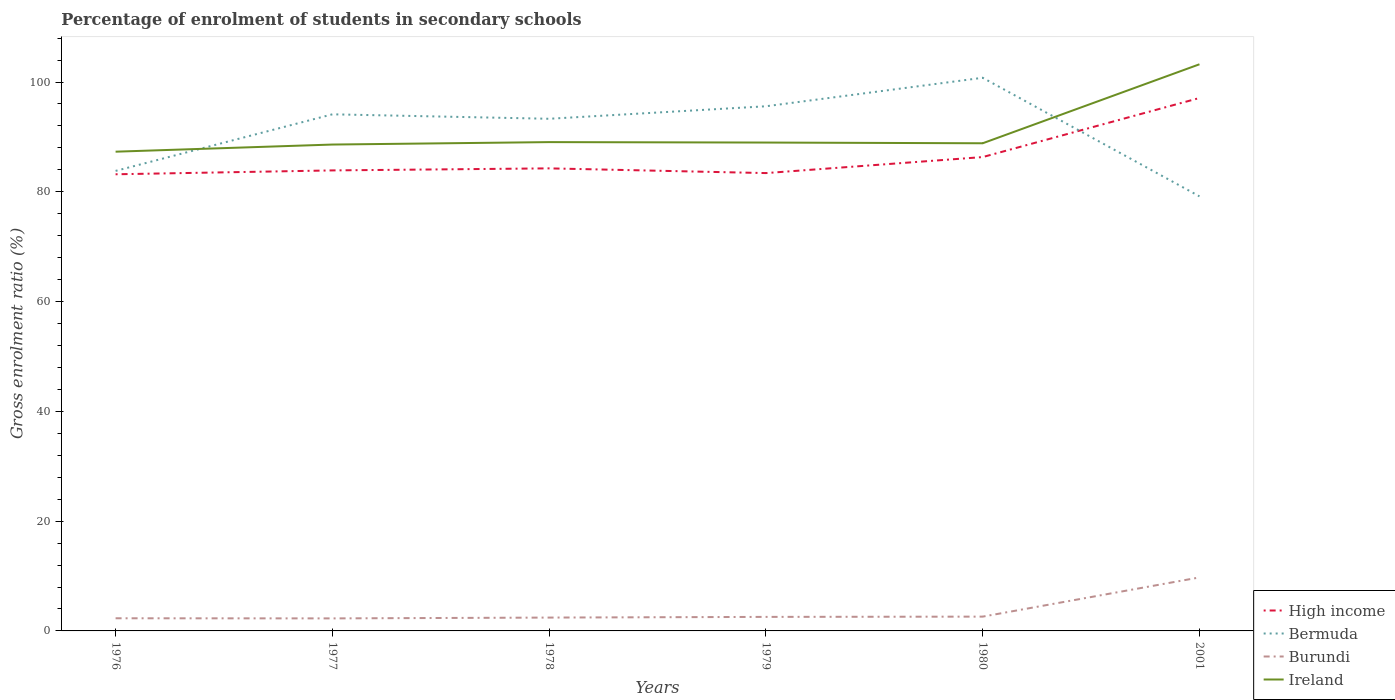How many different coloured lines are there?
Your answer should be compact. 4. Is the number of lines equal to the number of legend labels?
Offer a terse response. Yes. Across all years, what is the maximum percentage of students enrolled in secondary schools in Bermuda?
Keep it short and to the point. 79.17. In which year was the percentage of students enrolled in secondary schools in High income maximum?
Your response must be concise. 1976. What is the total percentage of students enrolled in secondary schools in Bermuda in the graph?
Your response must be concise. 21.6. What is the difference between the highest and the second highest percentage of students enrolled in secondary schools in Bermuda?
Make the answer very short. 21.6. Is the percentage of students enrolled in secondary schools in High income strictly greater than the percentage of students enrolled in secondary schools in Ireland over the years?
Ensure brevity in your answer.  Yes. How many years are there in the graph?
Keep it short and to the point. 6. Does the graph contain any zero values?
Make the answer very short. No. Does the graph contain grids?
Provide a succinct answer. No. What is the title of the graph?
Offer a very short reply. Percentage of enrolment of students in secondary schools. Does "Ghana" appear as one of the legend labels in the graph?
Your response must be concise. No. What is the label or title of the Y-axis?
Provide a short and direct response. Gross enrolment ratio (%). What is the Gross enrolment ratio (%) in High income in 1976?
Give a very brief answer. 83.19. What is the Gross enrolment ratio (%) of Bermuda in 1976?
Offer a terse response. 83.81. What is the Gross enrolment ratio (%) of Burundi in 1976?
Your answer should be compact. 2.3. What is the Gross enrolment ratio (%) of Ireland in 1976?
Your answer should be compact. 87.31. What is the Gross enrolment ratio (%) in High income in 1977?
Keep it short and to the point. 83.9. What is the Gross enrolment ratio (%) in Bermuda in 1977?
Give a very brief answer. 94.12. What is the Gross enrolment ratio (%) of Burundi in 1977?
Offer a very short reply. 2.28. What is the Gross enrolment ratio (%) in Ireland in 1977?
Your answer should be compact. 88.61. What is the Gross enrolment ratio (%) in High income in 1978?
Give a very brief answer. 84.27. What is the Gross enrolment ratio (%) of Bermuda in 1978?
Your answer should be compact. 93.31. What is the Gross enrolment ratio (%) in Burundi in 1978?
Offer a terse response. 2.43. What is the Gross enrolment ratio (%) of Ireland in 1978?
Keep it short and to the point. 89.05. What is the Gross enrolment ratio (%) in High income in 1979?
Give a very brief answer. 83.41. What is the Gross enrolment ratio (%) in Bermuda in 1979?
Keep it short and to the point. 95.59. What is the Gross enrolment ratio (%) of Burundi in 1979?
Give a very brief answer. 2.56. What is the Gross enrolment ratio (%) in Ireland in 1979?
Offer a terse response. 88.98. What is the Gross enrolment ratio (%) of High income in 1980?
Give a very brief answer. 86.33. What is the Gross enrolment ratio (%) of Bermuda in 1980?
Offer a terse response. 100.78. What is the Gross enrolment ratio (%) in Burundi in 1980?
Provide a succinct answer. 2.6. What is the Gross enrolment ratio (%) of Ireland in 1980?
Offer a very short reply. 88.84. What is the Gross enrolment ratio (%) in High income in 2001?
Your response must be concise. 97.09. What is the Gross enrolment ratio (%) of Bermuda in 2001?
Keep it short and to the point. 79.17. What is the Gross enrolment ratio (%) of Burundi in 2001?
Give a very brief answer. 9.75. What is the Gross enrolment ratio (%) of Ireland in 2001?
Provide a short and direct response. 103.23. Across all years, what is the maximum Gross enrolment ratio (%) of High income?
Offer a terse response. 97.09. Across all years, what is the maximum Gross enrolment ratio (%) in Bermuda?
Ensure brevity in your answer.  100.78. Across all years, what is the maximum Gross enrolment ratio (%) in Burundi?
Offer a very short reply. 9.75. Across all years, what is the maximum Gross enrolment ratio (%) in Ireland?
Ensure brevity in your answer.  103.23. Across all years, what is the minimum Gross enrolment ratio (%) in High income?
Ensure brevity in your answer.  83.19. Across all years, what is the minimum Gross enrolment ratio (%) of Bermuda?
Make the answer very short. 79.17. Across all years, what is the minimum Gross enrolment ratio (%) of Burundi?
Make the answer very short. 2.28. Across all years, what is the minimum Gross enrolment ratio (%) of Ireland?
Offer a very short reply. 87.31. What is the total Gross enrolment ratio (%) of High income in the graph?
Offer a very short reply. 518.2. What is the total Gross enrolment ratio (%) of Bermuda in the graph?
Your response must be concise. 546.77. What is the total Gross enrolment ratio (%) of Burundi in the graph?
Offer a very short reply. 21.92. What is the total Gross enrolment ratio (%) in Ireland in the graph?
Provide a short and direct response. 546.03. What is the difference between the Gross enrolment ratio (%) in High income in 1976 and that in 1977?
Offer a very short reply. -0.71. What is the difference between the Gross enrolment ratio (%) of Bermuda in 1976 and that in 1977?
Provide a succinct answer. -10.31. What is the difference between the Gross enrolment ratio (%) of Burundi in 1976 and that in 1977?
Make the answer very short. 0.02. What is the difference between the Gross enrolment ratio (%) of Ireland in 1976 and that in 1977?
Provide a succinct answer. -1.3. What is the difference between the Gross enrolment ratio (%) in High income in 1976 and that in 1978?
Provide a succinct answer. -1.08. What is the difference between the Gross enrolment ratio (%) in Bermuda in 1976 and that in 1978?
Keep it short and to the point. -9.5. What is the difference between the Gross enrolment ratio (%) in Burundi in 1976 and that in 1978?
Your answer should be compact. -0.13. What is the difference between the Gross enrolment ratio (%) of Ireland in 1976 and that in 1978?
Offer a very short reply. -1.75. What is the difference between the Gross enrolment ratio (%) in High income in 1976 and that in 1979?
Give a very brief answer. -0.22. What is the difference between the Gross enrolment ratio (%) in Bermuda in 1976 and that in 1979?
Make the answer very short. -11.78. What is the difference between the Gross enrolment ratio (%) of Burundi in 1976 and that in 1979?
Ensure brevity in your answer.  -0.25. What is the difference between the Gross enrolment ratio (%) of Ireland in 1976 and that in 1979?
Your response must be concise. -1.67. What is the difference between the Gross enrolment ratio (%) in High income in 1976 and that in 1980?
Your answer should be compact. -3.13. What is the difference between the Gross enrolment ratio (%) of Bermuda in 1976 and that in 1980?
Offer a very short reply. -16.97. What is the difference between the Gross enrolment ratio (%) in Burundi in 1976 and that in 1980?
Ensure brevity in your answer.  -0.3. What is the difference between the Gross enrolment ratio (%) of Ireland in 1976 and that in 1980?
Keep it short and to the point. -1.53. What is the difference between the Gross enrolment ratio (%) of High income in 1976 and that in 2001?
Provide a short and direct response. -13.9. What is the difference between the Gross enrolment ratio (%) in Bermuda in 1976 and that in 2001?
Give a very brief answer. 4.63. What is the difference between the Gross enrolment ratio (%) of Burundi in 1976 and that in 2001?
Your response must be concise. -7.44. What is the difference between the Gross enrolment ratio (%) of Ireland in 1976 and that in 2001?
Ensure brevity in your answer.  -15.93. What is the difference between the Gross enrolment ratio (%) in High income in 1977 and that in 1978?
Ensure brevity in your answer.  -0.37. What is the difference between the Gross enrolment ratio (%) in Bermuda in 1977 and that in 1978?
Provide a succinct answer. 0.81. What is the difference between the Gross enrolment ratio (%) in Burundi in 1977 and that in 1978?
Provide a succinct answer. -0.15. What is the difference between the Gross enrolment ratio (%) of Ireland in 1977 and that in 1978?
Keep it short and to the point. -0.44. What is the difference between the Gross enrolment ratio (%) in High income in 1977 and that in 1979?
Make the answer very short. 0.49. What is the difference between the Gross enrolment ratio (%) in Bermuda in 1977 and that in 1979?
Provide a short and direct response. -1.47. What is the difference between the Gross enrolment ratio (%) in Burundi in 1977 and that in 1979?
Keep it short and to the point. -0.27. What is the difference between the Gross enrolment ratio (%) of Ireland in 1977 and that in 1979?
Your answer should be very brief. -0.36. What is the difference between the Gross enrolment ratio (%) in High income in 1977 and that in 1980?
Keep it short and to the point. -2.43. What is the difference between the Gross enrolment ratio (%) of Bermuda in 1977 and that in 1980?
Your response must be concise. -6.66. What is the difference between the Gross enrolment ratio (%) in Burundi in 1977 and that in 1980?
Offer a very short reply. -0.32. What is the difference between the Gross enrolment ratio (%) in Ireland in 1977 and that in 1980?
Your answer should be compact. -0.23. What is the difference between the Gross enrolment ratio (%) in High income in 1977 and that in 2001?
Your response must be concise. -13.19. What is the difference between the Gross enrolment ratio (%) in Bermuda in 1977 and that in 2001?
Offer a terse response. 14.94. What is the difference between the Gross enrolment ratio (%) in Burundi in 1977 and that in 2001?
Your answer should be very brief. -7.46. What is the difference between the Gross enrolment ratio (%) in Ireland in 1977 and that in 2001?
Make the answer very short. -14.62. What is the difference between the Gross enrolment ratio (%) in High income in 1978 and that in 1979?
Your response must be concise. 0.86. What is the difference between the Gross enrolment ratio (%) of Bermuda in 1978 and that in 1979?
Provide a succinct answer. -2.28. What is the difference between the Gross enrolment ratio (%) of Burundi in 1978 and that in 1979?
Offer a terse response. -0.12. What is the difference between the Gross enrolment ratio (%) of Ireland in 1978 and that in 1979?
Your answer should be very brief. 0.08. What is the difference between the Gross enrolment ratio (%) in High income in 1978 and that in 1980?
Provide a succinct answer. -2.06. What is the difference between the Gross enrolment ratio (%) in Bermuda in 1978 and that in 1980?
Offer a terse response. -7.47. What is the difference between the Gross enrolment ratio (%) of Burundi in 1978 and that in 1980?
Keep it short and to the point. -0.17. What is the difference between the Gross enrolment ratio (%) of Ireland in 1978 and that in 1980?
Ensure brevity in your answer.  0.21. What is the difference between the Gross enrolment ratio (%) of High income in 1978 and that in 2001?
Keep it short and to the point. -12.82. What is the difference between the Gross enrolment ratio (%) in Bermuda in 1978 and that in 2001?
Offer a very short reply. 14.13. What is the difference between the Gross enrolment ratio (%) in Burundi in 1978 and that in 2001?
Keep it short and to the point. -7.31. What is the difference between the Gross enrolment ratio (%) in Ireland in 1978 and that in 2001?
Give a very brief answer. -14.18. What is the difference between the Gross enrolment ratio (%) in High income in 1979 and that in 1980?
Your answer should be very brief. -2.92. What is the difference between the Gross enrolment ratio (%) of Bermuda in 1979 and that in 1980?
Keep it short and to the point. -5.19. What is the difference between the Gross enrolment ratio (%) in Burundi in 1979 and that in 1980?
Provide a short and direct response. -0.05. What is the difference between the Gross enrolment ratio (%) of Ireland in 1979 and that in 1980?
Make the answer very short. 0.13. What is the difference between the Gross enrolment ratio (%) in High income in 1979 and that in 2001?
Ensure brevity in your answer.  -13.68. What is the difference between the Gross enrolment ratio (%) of Bermuda in 1979 and that in 2001?
Provide a succinct answer. 16.41. What is the difference between the Gross enrolment ratio (%) in Burundi in 1979 and that in 2001?
Provide a short and direct response. -7.19. What is the difference between the Gross enrolment ratio (%) in Ireland in 1979 and that in 2001?
Provide a succinct answer. -14.26. What is the difference between the Gross enrolment ratio (%) of High income in 1980 and that in 2001?
Your response must be concise. -10.76. What is the difference between the Gross enrolment ratio (%) of Bermuda in 1980 and that in 2001?
Offer a very short reply. 21.6. What is the difference between the Gross enrolment ratio (%) in Burundi in 1980 and that in 2001?
Give a very brief answer. -7.14. What is the difference between the Gross enrolment ratio (%) of Ireland in 1980 and that in 2001?
Keep it short and to the point. -14.39. What is the difference between the Gross enrolment ratio (%) in High income in 1976 and the Gross enrolment ratio (%) in Bermuda in 1977?
Give a very brief answer. -10.92. What is the difference between the Gross enrolment ratio (%) in High income in 1976 and the Gross enrolment ratio (%) in Burundi in 1977?
Your answer should be compact. 80.91. What is the difference between the Gross enrolment ratio (%) of High income in 1976 and the Gross enrolment ratio (%) of Ireland in 1977?
Give a very brief answer. -5.42. What is the difference between the Gross enrolment ratio (%) of Bermuda in 1976 and the Gross enrolment ratio (%) of Burundi in 1977?
Your response must be concise. 81.53. What is the difference between the Gross enrolment ratio (%) in Bermuda in 1976 and the Gross enrolment ratio (%) in Ireland in 1977?
Ensure brevity in your answer.  -4.8. What is the difference between the Gross enrolment ratio (%) of Burundi in 1976 and the Gross enrolment ratio (%) of Ireland in 1977?
Your answer should be compact. -86.31. What is the difference between the Gross enrolment ratio (%) in High income in 1976 and the Gross enrolment ratio (%) in Bermuda in 1978?
Make the answer very short. -10.11. What is the difference between the Gross enrolment ratio (%) of High income in 1976 and the Gross enrolment ratio (%) of Burundi in 1978?
Offer a very short reply. 80.76. What is the difference between the Gross enrolment ratio (%) in High income in 1976 and the Gross enrolment ratio (%) in Ireland in 1978?
Provide a short and direct response. -5.86. What is the difference between the Gross enrolment ratio (%) of Bermuda in 1976 and the Gross enrolment ratio (%) of Burundi in 1978?
Your response must be concise. 81.38. What is the difference between the Gross enrolment ratio (%) in Bermuda in 1976 and the Gross enrolment ratio (%) in Ireland in 1978?
Provide a short and direct response. -5.25. What is the difference between the Gross enrolment ratio (%) of Burundi in 1976 and the Gross enrolment ratio (%) of Ireland in 1978?
Offer a very short reply. -86.75. What is the difference between the Gross enrolment ratio (%) in High income in 1976 and the Gross enrolment ratio (%) in Bermuda in 1979?
Offer a terse response. -12.39. What is the difference between the Gross enrolment ratio (%) of High income in 1976 and the Gross enrolment ratio (%) of Burundi in 1979?
Keep it short and to the point. 80.64. What is the difference between the Gross enrolment ratio (%) in High income in 1976 and the Gross enrolment ratio (%) in Ireland in 1979?
Ensure brevity in your answer.  -5.78. What is the difference between the Gross enrolment ratio (%) in Bermuda in 1976 and the Gross enrolment ratio (%) in Burundi in 1979?
Make the answer very short. 81.25. What is the difference between the Gross enrolment ratio (%) in Bermuda in 1976 and the Gross enrolment ratio (%) in Ireland in 1979?
Your answer should be compact. -5.17. What is the difference between the Gross enrolment ratio (%) in Burundi in 1976 and the Gross enrolment ratio (%) in Ireland in 1979?
Your answer should be very brief. -86.67. What is the difference between the Gross enrolment ratio (%) in High income in 1976 and the Gross enrolment ratio (%) in Bermuda in 1980?
Ensure brevity in your answer.  -17.58. What is the difference between the Gross enrolment ratio (%) in High income in 1976 and the Gross enrolment ratio (%) in Burundi in 1980?
Ensure brevity in your answer.  80.59. What is the difference between the Gross enrolment ratio (%) of High income in 1976 and the Gross enrolment ratio (%) of Ireland in 1980?
Provide a succinct answer. -5.65. What is the difference between the Gross enrolment ratio (%) in Bermuda in 1976 and the Gross enrolment ratio (%) in Burundi in 1980?
Keep it short and to the point. 81.2. What is the difference between the Gross enrolment ratio (%) in Bermuda in 1976 and the Gross enrolment ratio (%) in Ireland in 1980?
Provide a short and direct response. -5.04. What is the difference between the Gross enrolment ratio (%) in Burundi in 1976 and the Gross enrolment ratio (%) in Ireland in 1980?
Offer a very short reply. -86.54. What is the difference between the Gross enrolment ratio (%) of High income in 1976 and the Gross enrolment ratio (%) of Bermuda in 2001?
Offer a terse response. 4.02. What is the difference between the Gross enrolment ratio (%) of High income in 1976 and the Gross enrolment ratio (%) of Burundi in 2001?
Keep it short and to the point. 73.45. What is the difference between the Gross enrolment ratio (%) of High income in 1976 and the Gross enrolment ratio (%) of Ireland in 2001?
Your response must be concise. -20.04. What is the difference between the Gross enrolment ratio (%) of Bermuda in 1976 and the Gross enrolment ratio (%) of Burundi in 2001?
Ensure brevity in your answer.  74.06. What is the difference between the Gross enrolment ratio (%) of Bermuda in 1976 and the Gross enrolment ratio (%) of Ireland in 2001?
Your answer should be very brief. -19.43. What is the difference between the Gross enrolment ratio (%) in Burundi in 1976 and the Gross enrolment ratio (%) in Ireland in 2001?
Make the answer very short. -100.93. What is the difference between the Gross enrolment ratio (%) in High income in 1977 and the Gross enrolment ratio (%) in Bermuda in 1978?
Your answer should be very brief. -9.41. What is the difference between the Gross enrolment ratio (%) of High income in 1977 and the Gross enrolment ratio (%) of Burundi in 1978?
Give a very brief answer. 81.47. What is the difference between the Gross enrolment ratio (%) in High income in 1977 and the Gross enrolment ratio (%) in Ireland in 1978?
Make the answer very short. -5.15. What is the difference between the Gross enrolment ratio (%) in Bermuda in 1977 and the Gross enrolment ratio (%) in Burundi in 1978?
Give a very brief answer. 91.69. What is the difference between the Gross enrolment ratio (%) in Bermuda in 1977 and the Gross enrolment ratio (%) in Ireland in 1978?
Offer a terse response. 5.06. What is the difference between the Gross enrolment ratio (%) in Burundi in 1977 and the Gross enrolment ratio (%) in Ireland in 1978?
Your answer should be very brief. -86.77. What is the difference between the Gross enrolment ratio (%) in High income in 1977 and the Gross enrolment ratio (%) in Bermuda in 1979?
Ensure brevity in your answer.  -11.69. What is the difference between the Gross enrolment ratio (%) of High income in 1977 and the Gross enrolment ratio (%) of Burundi in 1979?
Provide a succinct answer. 81.34. What is the difference between the Gross enrolment ratio (%) in High income in 1977 and the Gross enrolment ratio (%) in Ireland in 1979?
Provide a succinct answer. -5.08. What is the difference between the Gross enrolment ratio (%) in Bermuda in 1977 and the Gross enrolment ratio (%) in Burundi in 1979?
Your answer should be very brief. 91.56. What is the difference between the Gross enrolment ratio (%) in Bermuda in 1977 and the Gross enrolment ratio (%) in Ireland in 1979?
Provide a succinct answer. 5.14. What is the difference between the Gross enrolment ratio (%) in Burundi in 1977 and the Gross enrolment ratio (%) in Ireland in 1979?
Keep it short and to the point. -86.69. What is the difference between the Gross enrolment ratio (%) in High income in 1977 and the Gross enrolment ratio (%) in Bermuda in 1980?
Provide a succinct answer. -16.88. What is the difference between the Gross enrolment ratio (%) in High income in 1977 and the Gross enrolment ratio (%) in Burundi in 1980?
Keep it short and to the point. 81.3. What is the difference between the Gross enrolment ratio (%) of High income in 1977 and the Gross enrolment ratio (%) of Ireland in 1980?
Give a very brief answer. -4.94. What is the difference between the Gross enrolment ratio (%) of Bermuda in 1977 and the Gross enrolment ratio (%) of Burundi in 1980?
Make the answer very short. 91.51. What is the difference between the Gross enrolment ratio (%) of Bermuda in 1977 and the Gross enrolment ratio (%) of Ireland in 1980?
Provide a short and direct response. 5.28. What is the difference between the Gross enrolment ratio (%) in Burundi in 1977 and the Gross enrolment ratio (%) in Ireland in 1980?
Provide a short and direct response. -86.56. What is the difference between the Gross enrolment ratio (%) in High income in 1977 and the Gross enrolment ratio (%) in Bermuda in 2001?
Keep it short and to the point. 4.73. What is the difference between the Gross enrolment ratio (%) in High income in 1977 and the Gross enrolment ratio (%) in Burundi in 2001?
Make the answer very short. 74.15. What is the difference between the Gross enrolment ratio (%) in High income in 1977 and the Gross enrolment ratio (%) in Ireland in 2001?
Offer a very short reply. -19.33. What is the difference between the Gross enrolment ratio (%) of Bermuda in 1977 and the Gross enrolment ratio (%) of Burundi in 2001?
Offer a very short reply. 84.37. What is the difference between the Gross enrolment ratio (%) of Bermuda in 1977 and the Gross enrolment ratio (%) of Ireland in 2001?
Keep it short and to the point. -9.12. What is the difference between the Gross enrolment ratio (%) of Burundi in 1977 and the Gross enrolment ratio (%) of Ireland in 2001?
Provide a succinct answer. -100.95. What is the difference between the Gross enrolment ratio (%) in High income in 1978 and the Gross enrolment ratio (%) in Bermuda in 1979?
Make the answer very short. -11.31. What is the difference between the Gross enrolment ratio (%) in High income in 1978 and the Gross enrolment ratio (%) in Burundi in 1979?
Your answer should be very brief. 81.72. What is the difference between the Gross enrolment ratio (%) of High income in 1978 and the Gross enrolment ratio (%) of Ireland in 1979?
Offer a very short reply. -4.7. What is the difference between the Gross enrolment ratio (%) of Bermuda in 1978 and the Gross enrolment ratio (%) of Burundi in 1979?
Make the answer very short. 90.75. What is the difference between the Gross enrolment ratio (%) in Bermuda in 1978 and the Gross enrolment ratio (%) in Ireland in 1979?
Give a very brief answer. 4.33. What is the difference between the Gross enrolment ratio (%) in Burundi in 1978 and the Gross enrolment ratio (%) in Ireland in 1979?
Your answer should be very brief. -86.54. What is the difference between the Gross enrolment ratio (%) of High income in 1978 and the Gross enrolment ratio (%) of Bermuda in 1980?
Offer a very short reply. -16.5. What is the difference between the Gross enrolment ratio (%) of High income in 1978 and the Gross enrolment ratio (%) of Burundi in 1980?
Give a very brief answer. 81.67. What is the difference between the Gross enrolment ratio (%) in High income in 1978 and the Gross enrolment ratio (%) in Ireland in 1980?
Your response must be concise. -4.57. What is the difference between the Gross enrolment ratio (%) of Bermuda in 1978 and the Gross enrolment ratio (%) of Burundi in 1980?
Provide a short and direct response. 90.7. What is the difference between the Gross enrolment ratio (%) in Bermuda in 1978 and the Gross enrolment ratio (%) in Ireland in 1980?
Offer a terse response. 4.46. What is the difference between the Gross enrolment ratio (%) of Burundi in 1978 and the Gross enrolment ratio (%) of Ireland in 1980?
Offer a very short reply. -86.41. What is the difference between the Gross enrolment ratio (%) of High income in 1978 and the Gross enrolment ratio (%) of Bermuda in 2001?
Provide a short and direct response. 5.1. What is the difference between the Gross enrolment ratio (%) of High income in 1978 and the Gross enrolment ratio (%) of Burundi in 2001?
Your answer should be compact. 74.53. What is the difference between the Gross enrolment ratio (%) in High income in 1978 and the Gross enrolment ratio (%) in Ireland in 2001?
Offer a very short reply. -18.96. What is the difference between the Gross enrolment ratio (%) of Bermuda in 1978 and the Gross enrolment ratio (%) of Burundi in 2001?
Your response must be concise. 83.56. What is the difference between the Gross enrolment ratio (%) in Bermuda in 1978 and the Gross enrolment ratio (%) in Ireland in 2001?
Make the answer very short. -9.93. What is the difference between the Gross enrolment ratio (%) in Burundi in 1978 and the Gross enrolment ratio (%) in Ireland in 2001?
Give a very brief answer. -100.8. What is the difference between the Gross enrolment ratio (%) in High income in 1979 and the Gross enrolment ratio (%) in Bermuda in 1980?
Offer a terse response. -17.36. What is the difference between the Gross enrolment ratio (%) in High income in 1979 and the Gross enrolment ratio (%) in Burundi in 1980?
Ensure brevity in your answer.  80.81. What is the difference between the Gross enrolment ratio (%) in High income in 1979 and the Gross enrolment ratio (%) in Ireland in 1980?
Your answer should be compact. -5.43. What is the difference between the Gross enrolment ratio (%) in Bermuda in 1979 and the Gross enrolment ratio (%) in Burundi in 1980?
Keep it short and to the point. 92.98. What is the difference between the Gross enrolment ratio (%) in Bermuda in 1979 and the Gross enrolment ratio (%) in Ireland in 1980?
Provide a succinct answer. 6.74. What is the difference between the Gross enrolment ratio (%) in Burundi in 1979 and the Gross enrolment ratio (%) in Ireland in 1980?
Ensure brevity in your answer.  -86.29. What is the difference between the Gross enrolment ratio (%) in High income in 1979 and the Gross enrolment ratio (%) in Bermuda in 2001?
Provide a short and direct response. 4.24. What is the difference between the Gross enrolment ratio (%) of High income in 1979 and the Gross enrolment ratio (%) of Burundi in 2001?
Your answer should be very brief. 73.67. What is the difference between the Gross enrolment ratio (%) of High income in 1979 and the Gross enrolment ratio (%) of Ireland in 2001?
Offer a terse response. -19.82. What is the difference between the Gross enrolment ratio (%) in Bermuda in 1979 and the Gross enrolment ratio (%) in Burundi in 2001?
Provide a short and direct response. 85.84. What is the difference between the Gross enrolment ratio (%) in Bermuda in 1979 and the Gross enrolment ratio (%) in Ireland in 2001?
Your answer should be compact. -7.65. What is the difference between the Gross enrolment ratio (%) in Burundi in 1979 and the Gross enrolment ratio (%) in Ireland in 2001?
Offer a very short reply. -100.68. What is the difference between the Gross enrolment ratio (%) in High income in 1980 and the Gross enrolment ratio (%) in Bermuda in 2001?
Ensure brevity in your answer.  7.15. What is the difference between the Gross enrolment ratio (%) in High income in 1980 and the Gross enrolment ratio (%) in Burundi in 2001?
Your answer should be very brief. 76.58. What is the difference between the Gross enrolment ratio (%) in High income in 1980 and the Gross enrolment ratio (%) in Ireland in 2001?
Your response must be concise. -16.91. What is the difference between the Gross enrolment ratio (%) in Bermuda in 1980 and the Gross enrolment ratio (%) in Burundi in 2001?
Provide a short and direct response. 91.03. What is the difference between the Gross enrolment ratio (%) in Bermuda in 1980 and the Gross enrolment ratio (%) in Ireland in 2001?
Your response must be concise. -2.46. What is the difference between the Gross enrolment ratio (%) in Burundi in 1980 and the Gross enrolment ratio (%) in Ireland in 2001?
Keep it short and to the point. -100.63. What is the average Gross enrolment ratio (%) in High income per year?
Offer a very short reply. 86.37. What is the average Gross enrolment ratio (%) of Bermuda per year?
Offer a very short reply. 91.13. What is the average Gross enrolment ratio (%) in Burundi per year?
Ensure brevity in your answer.  3.65. What is the average Gross enrolment ratio (%) in Ireland per year?
Provide a short and direct response. 91. In the year 1976, what is the difference between the Gross enrolment ratio (%) of High income and Gross enrolment ratio (%) of Bermuda?
Ensure brevity in your answer.  -0.61. In the year 1976, what is the difference between the Gross enrolment ratio (%) of High income and Gross enrolment ratio (%) of Burundi?
Keep it short and to the point. 80.89. In the year 1976, what is the difference between the Gross enrolment ratio (%) of High income and Gross enrolment ratio (%) of Ireland?
Offer a terse response. -4.11. In the year 1976, what is the difference between the Gross enrolment ratio (%) of Bermuda and Gross enrolment ratio (%) of Burundi?
Keep it short and to the point. 81.5. In the year 1976, what is the difference between the Gross enrolment ratio (%) in Bermuda and Gross enrolment ratio (%) in Ireland?
Provide a short and direct response. -3.5. In the year 1976, what is the difference between the Gross enrolment ratio (%) in Burundi and Gross enrolment ratio (%) in Ireland?
Give a very brief answer. -85. In the year 1977, what is the difference between the Gross enrolment ratio (%) in High income and Gross enrolment ratio (%) in Bermuda?
Your response must be concise. -10.22. In the year 1977, what is the difference between the Gross enrolment ratio (%) in High income and Gross enrolment ratio (%) in Burundi?
Provide a succinct answer. 81.62. In the year 1977, what is the difference between the Gross enrolment ratio (%) of High income and Gross enrolment ratio (%) of Ireland?
Keep it short and to the point. -4.71. In the year 1977, what is the difference between the Gross enrolment ratio (%) of Bermuda and Gross enrolment ratio (%) of Burundi?
Your answer should be compact. 91.84. In the year 1977, what is the difference between the Gross enrolment ratio (%) of Bermuda and Gross enrolment ratio (%) of Ireland?
Ensure brevity in your answer.  5.51. In the year 1977, what is the difference between the Gross enrolment ratio (%) in Burundi and Gross enrolment ratio (%) in Ireland?
Provide a succinct answer. -86.33. In the year 1978, what is the difference between the Gross enrolment ratio (%) of High income and Gross enrolment ratio (%) of Bermuda?
Your answer should be very brief. -9.03. In the year 1978, what is the difference between the Gross enrolment ratio (%) of High income and Gross enrolment ratio (%) of Burundi?
Give a very brief answer. 81.84. In the year 1978, what is the difference between the Gross enrolment ratio (%) in High income and Gross enrolment ratio (%) in Ireland?
Ensure brevity in your answer.  -4.78. In the year 1978, what is the difference between the Gross enrolment ratio (%) of Bermuda and Gross enrolment ratio (%) of Burundi?
Offer a terse response. 90.87. In the year 1978, what is the difference between the Gross enrolment ratio (%) in Bermuda and Gross enrolment ratio (%) in Ireland?
Provide a succinct answer. 4.25. In the year 1978, what is the difference between the Gross enrolment ratio (%) in Burundi and Gross enrolment ratio (%) in Ireland?
Provide a short and direct response. -86.62. In the year 1979, what is the difference between the Gross enrolment ratio (%) in High income and Gross enrolment ratio (%) in Bermuda?
Provide a succinct answer. -12.17. In the year 1979, what is the difference between the Gross enrolment ratio (%) in High income and Gross enrolment ratio (%) in Burundi?
Offer a terse response. 80.86. In the year 1979, what is the difference between the Gross enrolment ratio (%) of High income and Gross enrolment ratio (%) of Ireland?
Your answer should be very brief. -5.56. In the year 1979, what is the difference between the Gross enrolment ratio (%) in Bermuda and Gross enrolment ratio (%) in Burundi?
Your answer should be compact. 93.03. In the year 1979, what is the difference between the Gross enrolment ratio (%) of Bermuda and Gross enrolment ratio (%) of Ireland?
Provide a short and direct response. 6.61. In the year 1979, what is the difference between the Gross enrolment ratio (%) of Burundi and Gross enrolment ratio (%) of Ireland?
Offer a terse response. -86.42. In the year 1980, what is the difference between the Gross enrolment ratio (%) in High income and Gross enrolment ratio (%) in Bermuda?
Offer a very short reply. -14.45. In the year 1980, what is the difference between the Gross enrolment ratio (%) of High income and Gross enrolment ratio (%) of Burundi?
Offer a very short reply. 83.72. In the year 1980, what is the difference between the Gross enrolment ratio (%) of High income and Gross enrolment ratio (%) of Ireland?
Your response must be concise. -2.51. In the year 1980, what is the difference between the Gross enrolment ratio (%) in Bermuda and Gross enrolment ratio (%) in Burundi?
Offer a terse response. 98.17. In the year 1980, what is the difference between the Gross enrolment ratio (%) in Bermuda and Gross enrolment ratio (%) in Ireland?
Your answer should be compact. 11.93. In the year 1980, what is the difference between the Gross enrolment ratio (%) in Burundi and Gross enrolment ratio (%) in Ireland?
Your response must be concise. -86.24. In the year 2001, what is the difference between the Gross enrolment ratio (%) of High income and Gross enrolment ratio (%) of Bermuda?
Provide a succinct answer. 17.92. In the year 2001, what is the difference between the Gross enrolment ratio (%) in High income and Gross enrolment ratio (%) in Burundi?
Offer a terse response. 87.34. In the year 2001, what is the difference between the Gross enrolment ratio (%) of High income and Gross enrolment ratio (%) of Ireland?
Make the answer very short. -6.14. In the year 2001, what is the difference between the Gross enrolment ratio (%) of Bermuda and Gross enrolment ratio (%) of Burundi?
Ensure brevity in your answer.  69.43. In the year 2001, what is the difference between the Gross enrolment ratio (%) of Bermuda and Gross enrolment ratio (%) of Ireland?
Provide a short and direct response. -24.06. In the year 2001, what is the difference between the Gross enrolment ratio (%) of Burundi and Gross enrolment ratio (%) of Ireland?
Keep it short and to the point. -93.49. What is the ratio of the Gross enrolment ratio (%) of High income in 1976 to that in 1977?
Provide a short and direct response. 0.99. What is the ratio of the Gross enrolment ratio (%) of Bermuda in 1976 to that in 1977?
Your answer should be very brief. 0.89. What is the ratio of the Gross enrolment ratio (%) of High income in 1976 to that in 1978?
Your answer should be very brief. 0.99. What is the ratio of the Gross enrolment ratio (%) in Bermuda in 1976 to that in 1978?
Your answer should be very brief. 0.9. What is the ratio of the Gross enrolment ratio (%) in Burundi in 1976 to that in 1978?
Provide a short and direct response. 0.95. What is the ratio of the Gross enrolment ratio (%) in Ireland in 1976 to that in 1978?
Your response must be concise. 0.98. What is the ratio of the Gross enrolment ratio (%) of Bermuda in 1976 to that in 1979?
Offer a very short reply. 0.88. What is the ratio of the Gross enrolment ratio (%) in Burundi in 1976 to that in 1979?
Your response must be concise. 0.9. What is the ratio of the Gross enrolment ratio (%) in Ireland in 1976 to that in 1979?
Your response must be concise. 0.98. What is the ratio of the Gross enrolment ratio (%) of High income in 1976 to that in 1980?
Ensure brevity in your answer.  0.96. What is the ratio of the Gross enrolment ratio (%) in Bermuda in 1976 to that in 1980?
Make the answer very short. 0.83. What is the ratio of the Gross enrolment ratio (%) of Burundi in 1976 to that in 1980?
Offer a very short reply. 0.88. What is the ratio of the Gross enrolment ratio (%) in Ireland in 1976 to that in 1980?
Your answer should be very brief. 0.98. What is the ratio of the Gross enrolment ratio (%) of High income in 1976 to that in 2001?
Keep it short and to the point. 0.86. What is the ratio of the Gross enrolment ratio (%) in Bermuda in 1976 to that in 2001?
Your answer should be compact. 1.06. What is the ratio of the Gross enrolment ratio (%) of Burundi in 1976 to that in 2001?
Provide a succinct answer. 0.24. What is the ratio of the Gross enrolment ratio (%) in Ireland in 1976 to that in 2001?
Offer a very short reply. 0.85. What is the ratio of the Gross enrolment ratio (%) in Bermuda in 1977 to that in 1978?
Ensure brevity in your answer.  1.01. What is the ratio of the Gross enrolment ratio (%) in Burundi in 1977 to that in 1978?
Ensure brevity in your answer.  0.94. What is the ratio of the Gross enrolment ratio (%) of High income in 1977 to that in 1979?
Offer a very short reply. 1.01. What is the ratio of the Gross enrolment ratio (%) in Bermuda in 1977 to that in 1979?
Your answer should be compact. 0.98. What is the ratio of the Gross enrolment ratio (%) of Burundi in 1977 to that in 1979?
Give a very brief answer. 0.89. What is the ratio of the Gross enrolment ratio (%) in Ireland in 1977 to that in 1979?
Keep it short and to the point. 1. What is the ratio of the Gross enrolment ratio (%) in High income in 1977 to that in 1980?
Provide a short and direct response. 0.97. What is the ratio of the Gross enrolment ratio (%) of Bermuda in 1977 to that in 1980?
Your answer should be compact. 0.93. What is the ratio of the Gross enrolment ratio (%) in Burundi in 1977 to that in 1980?
Provide a succinct answer. 0.88. What is the ratio of the Gross enrolment ratio (%) in Ireland in 1977 to that in 1980?
Keep it short and to the point. 1. What is the ratio of the Gross enrolment ratio (%) of High income in 1977 to that in 2001?
Give a very brief answer. 0.86. What is the ratio of the Gross enrolment ratio (%) in Bermuda in 1977 to that in 2001?
Ensure brevity in your answer.  1.19. What is the ratio of the Gross enrolment ratio (%) of Burundi in 1977 to that in 2001?
Your answer should be very brief. 0.23. What is the ratio of the Gross enrolment ratio (%) of Ireland in 1977 to that in 2001?
Ensure brevity in your answer.  0.86. What is the ratio of the Gross enrolment ratio (%) of High income in 1978 to that in 1979?
Ensure brevity in your answer.  1.01. What is the ratio of the Gross enrolment ratio (%) in Bermuda in 1978 to that in 1979?
Offer a very short reply. 0.98. What is the ratio of the Gross enrolment ratio (%) of Burundi in 1978 to that in 1979?
Give a very brief answer. 0.95. What is the ratio of the Gross enrolment ratio (%) in Ireland in 1978 to that in 1979?
Make the answer very short. 1. What is the ratio of the Gross enrolment ratio (%) in High income in 1978 to that in 1980?
Give a very brief answer. 0.98. What is the ratio of the Gross enrolment ratio (%) of Bermuda in 1978 to that in 1980?
Make the answer very short. 0.93. What is the ratio of the Gross enrolment ratio (%) in Burundi in 1978 to that in 1980?
Provide a short and direct response. 0.93. What is the ratio of the Gross enrolment ratio (%) of Ireland in 1978 to that in 1980?
Keep it short and to the point. 1. What is the ratio of the Gross enrolment ratio (%) in High income in 1978 to that in 2001?
Ensure brevity in your answer.  0.87. What is the ratio of the Gross enrolment ratio (%) in Bermuda in 1978 to that in 2001?
Give a very brief answer. 1.18. What is the ratio of the Gross enrolment ratio (%) in Burundi in 1978 to that in 2001?
Make the answer very short. 0.25. What is the ratio of the Gross enrolment ratio (%) in Ireland in 1978 to that in 2001?
Your answer should be compact. 0.86. What is the ratio of the Gross enrolment ratio (%) in High income in 1979 to that in 1980?
Provide a short and direct response. 0.97. What is the ratio of the Gross enrolment ratio (%) in Bermuda in 1979 to that in 1980?
Your response must be concise. 0.95. What is the ratio of the Gross enrolment ratio (%) in Burundi in 1979 to that in 1980?
Your answer should be very brief. 0.98. What is the ratio of the Gross enrolment ratio (%) in High income in 1979 to that in 2001?
Your response must be concise. 0.86. What is the ratio of the Gross enrolment ratio (%) of Bermuda in 1979 to that in 2001?
Make the answer very short. 1.21. What is the ratio of the Gross enrolment ratio (%) in Burundi in 1979 to that in 2001?
Ensure brevity in your answer.  0.26. What is the ratio of the Gross enrolment ratio (%) of Ireland in 1979 to that in 2001?
Provide a succinct answer. 0.86. What is the ratio of the Gross enrolment ratio (%) in High income in 1980 to that in 2001?
Offer a very short reply. 0.89. What is the ratio of the Gross enrolment ratio (%) of Bermuda in 1980 to that in 2001?
Your response must be concise. 1.27. What is the ratio of the Gross enrolment ratio (%) in Burundi in 1980 to that in 2001?
Your answer should be compact. 0.27. What is the ratio of the Gross enrolment ratio (%) of Ireland in 1980 to that in 2001?
Provide a succinct answer. 0.86. What is the difference between the highest and the second highest Gross enrolment ratio (%) of High income?
Your answer should be compact. 10.76. What is the difference between the highest and the second highest Gross enrolment ratio (%) in Bermuda?
Your response must be concise. 5.19. What is the difference between the highest and the second highest Gross enrolment ratio (%) of Burundi?
Offer a very short reply. 7.14. What is the difference between the highest and the second highest Gross enrolment ratio (%) in Ireland?
Your answer should be compact. 14.18. What is the difference between the highest and the lowest Gross enrolment ratio (%) of High income?
Your response must be concise. 13.9. What is the difference between the highest and the lowest Gross enrolment ratio (%) of Bermuda?
Your answer should be very brief. 21.6. What is the difference between the highest and the lowest Gross enrolment ratio (%) in Burundi?
Keep it short and to the point. 7.46. What is the difference between the highest and the lowest Gross enrolment ratio (%) in Ireland?
Make the answer very short. 15.93. 